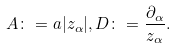<formula> <loc_0><loc_0><loc_500><loc_500>A \colon = a | z _ { \alpha } | , D \colon = \frac { \partial _ { \alpha } } { z _ { \alpha } } .</formula> 